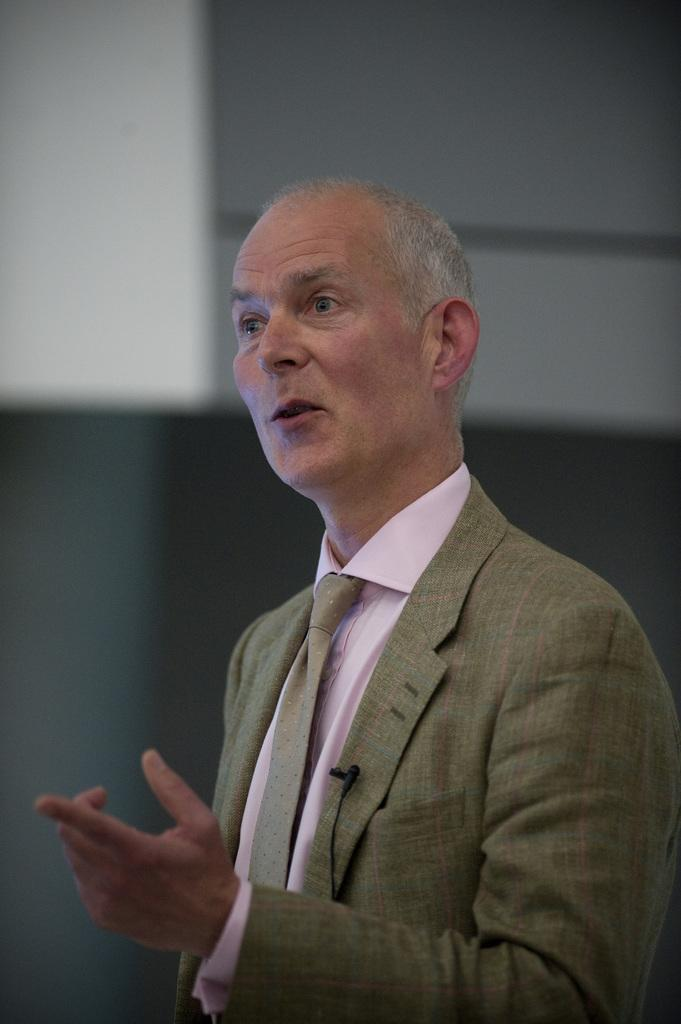Who is present in the image? There is a man in the image. What is the man doing in the image? The man is speaking in the image. What type of clothing is the man wearing? The man is wearing a tie, a shirt, and a coat. What object is the man holding in the image? The man is holding a microphone in the image. What type of zinc is present in the image? There is no zinc present in the image. What type of competition is the man participating in during the image? The image does not depict a competition, and there is no information about the man's participation in one. 